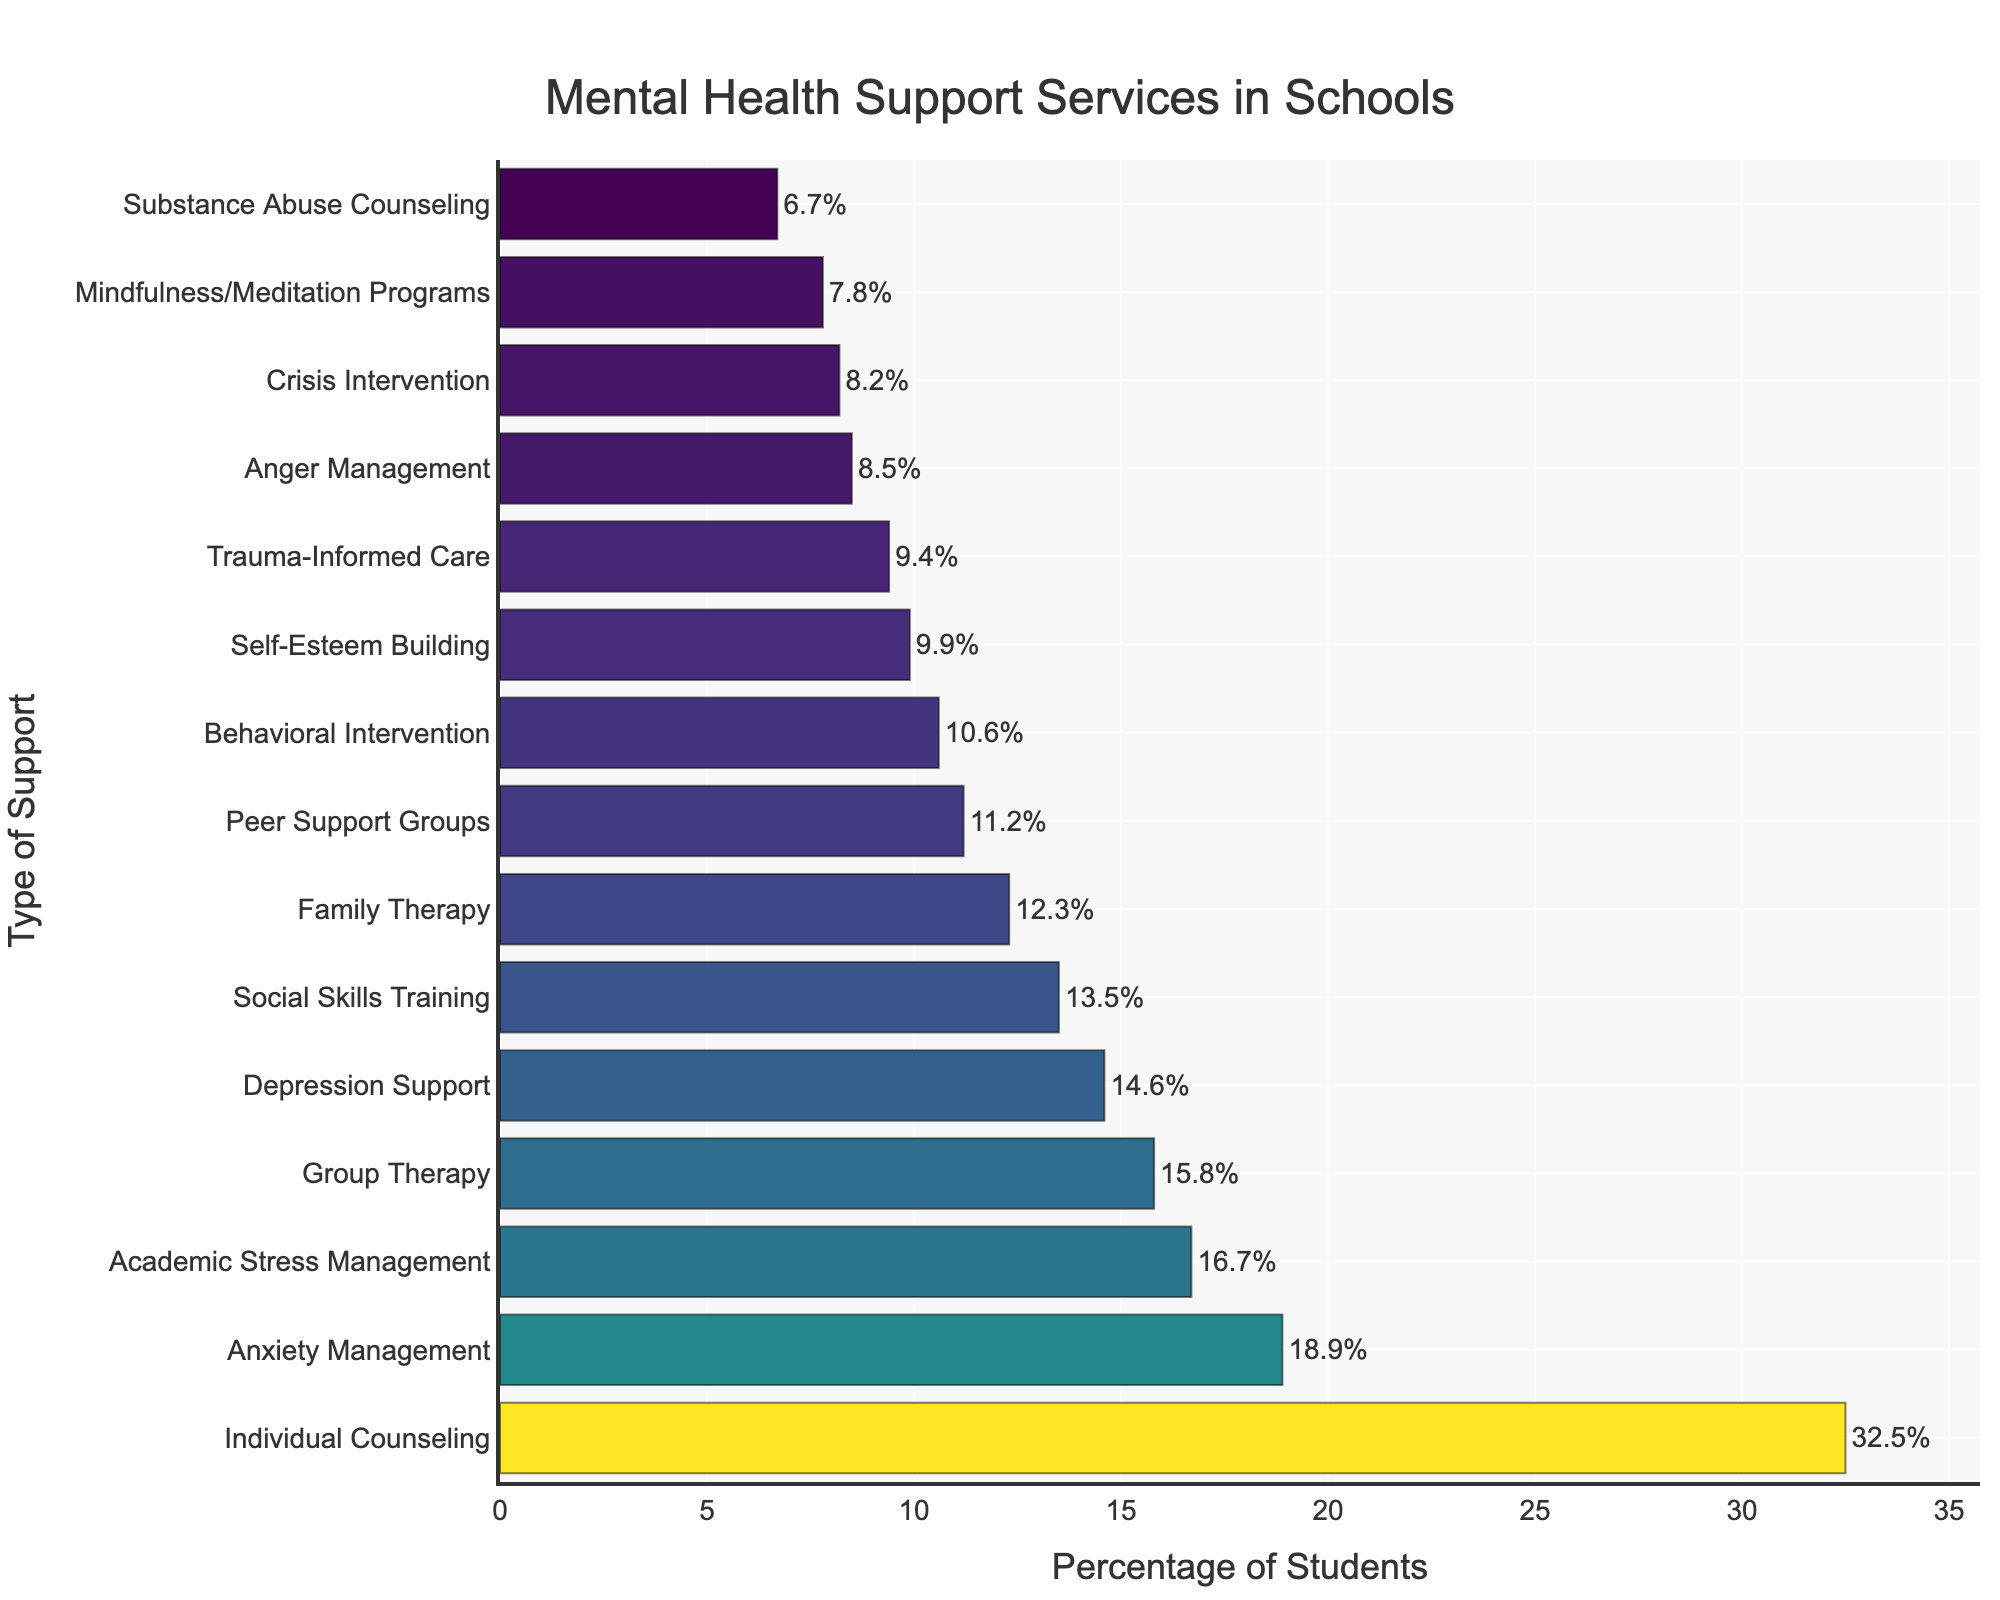What's the most common type of mental health support provided to students? The bar chart shows that Individual Counseling has the highest percentage bar, indicating it is the most common type of mental health support provided to students.
Answer: Individual Counseling Which two support services have the closest percentage of students receiving them? By comparing the lengths of bars, we see that Anger Management (8.5%) and Crisis Intervention (8.2%) have the closest percentage values.
Answer: Anger Management and Crisis Intervention How much higher is the percentage of students receiving Individual Counseling compared to those receiving Group Therapy? First, identify the percentages: Individual Counseling (32.5%) and Group Therapy (15.8%). Subtract Group Therapy from Individual Counseling: 32.5% - 15.8% = 16.7%.
Answer: 16.7% Which type of support has a higher percentage of students, Depression Support or Family Therapy? Observing the bar lengths, Depression Support (14.6%) has a slightly higher percentage than Family Therapy (12.3%).
Answer: Depression Support What is the combined percentage of students receiving Anxiety Management and Academic Stress Management? Summing up the percentages for Anxiety Management (18.9%) and Academic Stress Management (16.7%) gives: 18.9% + 16.7% = 35.6%.
Answer: 35.6% How many types of support have a percentage of students receiving them above 15%? By observing the bar lengths, the types of support with percentages above 15% are Individual Counseling (32.5%), Group Therapy (15.8%), Anxiety Management (18.9%), and Academic Stress Management (16.7%). There are 4 types.
Answer: 4 What percentage of students are receiving Behavioral Intervention support? The chart shows that the percentage of students receiving Behavioral Intervention is 10.6%.
Answer: 10.6% Which type of support has the smallest percentage of students receiving it? The smallest bar on the chart is for Substance Abuse Counseling, indicating it has the lowest percentage at 6.7%.
Answer: Substance Abuse Counseling Are there more students receiving Peer Support Groups or Social Skills Training? Comparing bar lengths, Social Skills Training (13.5%) has a higher percentage than Peer Support Groups (11.2%).
Answer: Social Skills Training What is the difference in percentage points between Family Therapy and Behavioral Intervention? First, identify the percentages: Family Therapy (12.3%) and Behavioral Intervention (10.6%). Subtract Behavioral Intervention from Family Therapy: 12.3% - 10.6% = 1.7%.
Answer: 1.7% 